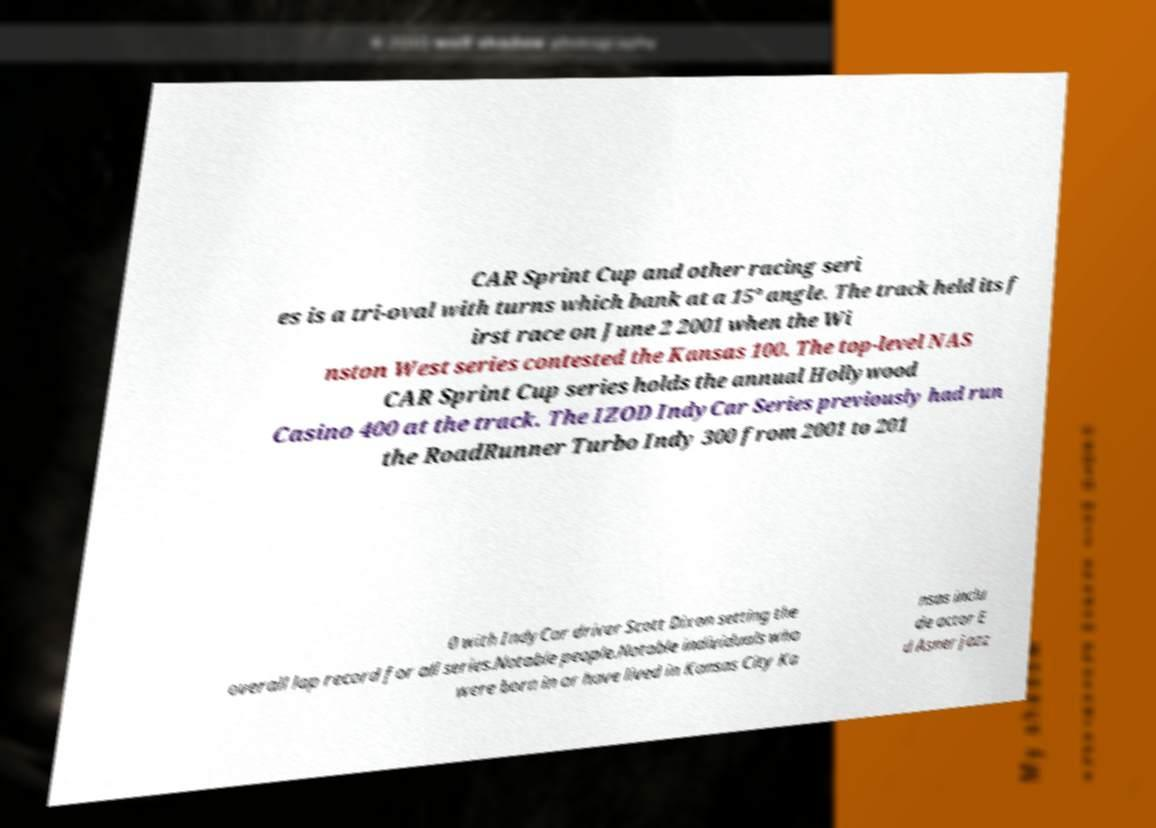Please read and relay the text visible in this image. What does it say? CAR Sprint Cup and other racing seri es is a tri-oval with turns which bank at a 15° angle. The track held its f irst race on June 2 2001 when the Wi nston West series contested the Kansas 100. The top-level NAS CAR Sprint Cup series holds the annual Hollywood Casino 400 at the track. The IZOD IndyCar Series previously had run the RoadRunner Turbo Indy 300 from 2001 to 201 0 with IndyCar driver Scott Dixon setting the overall lap record for all series.Notable people.Notable individuals who were born in or have lived in Kansas City Ka nsas inclu de actor E d Asner jazz 